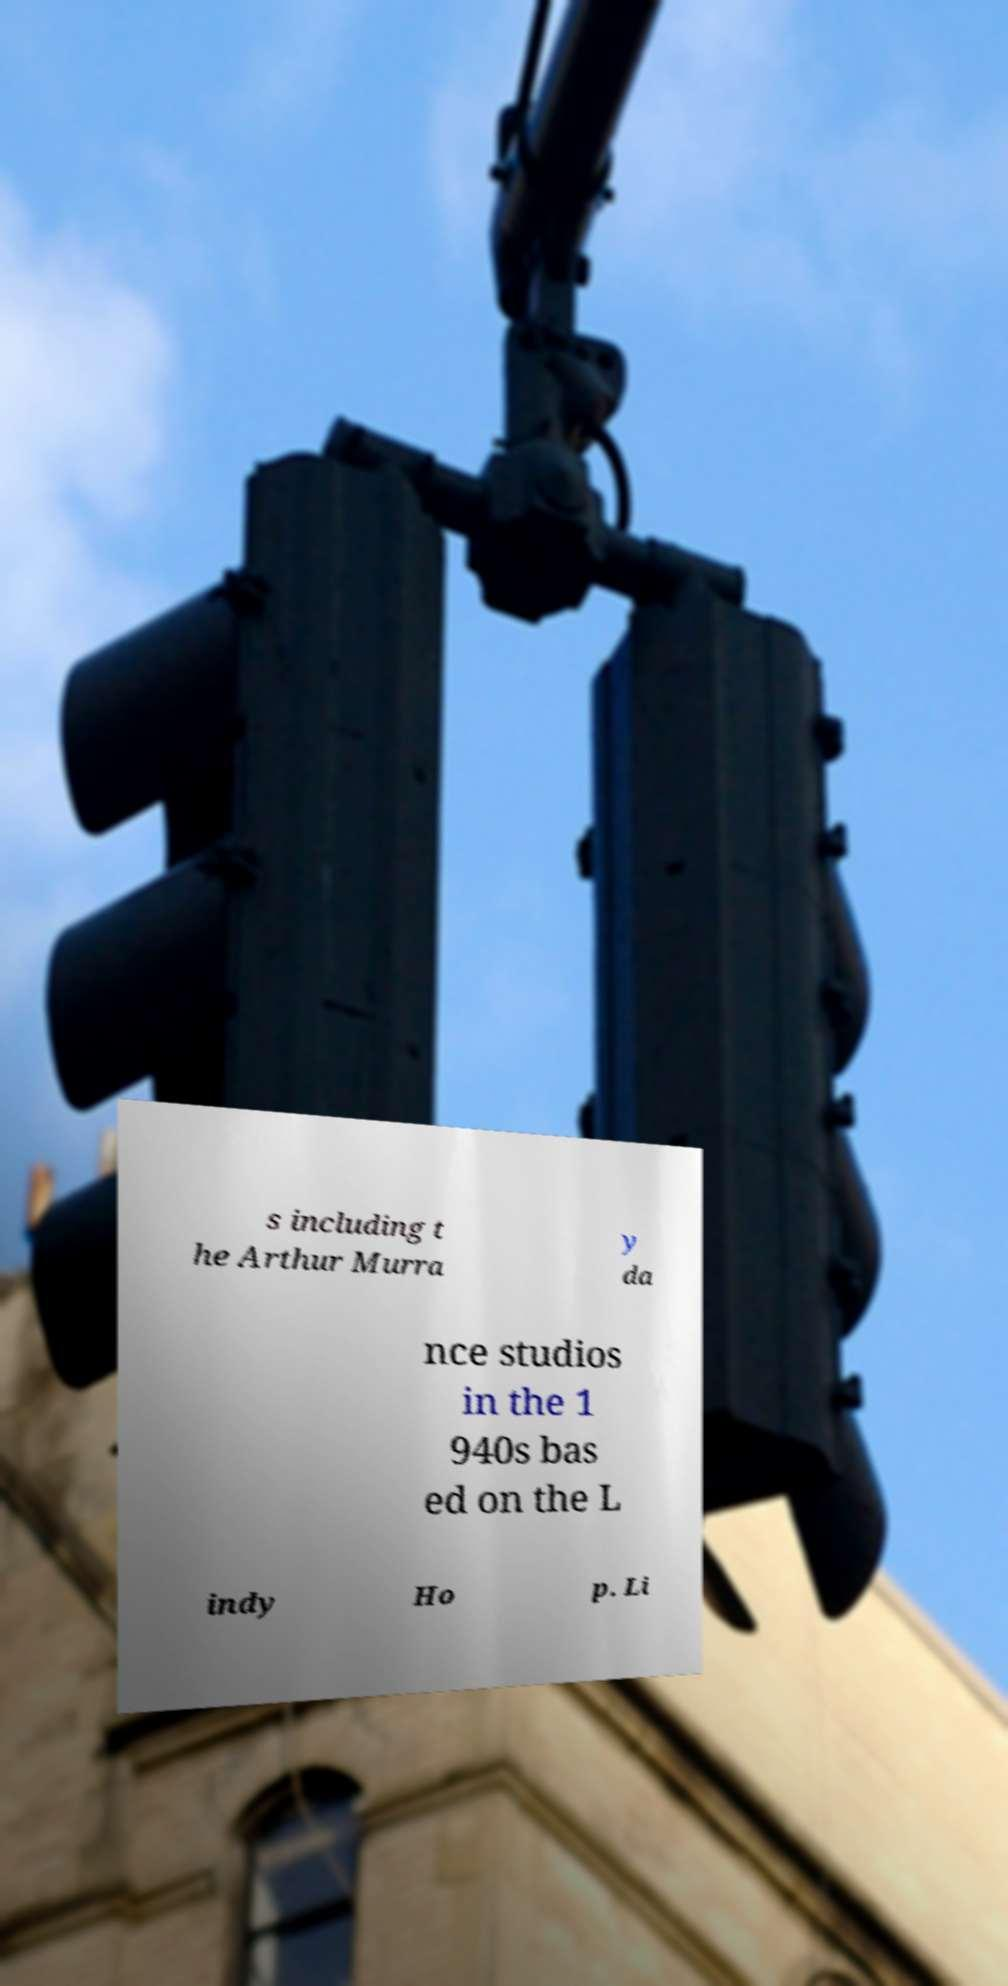Can you read and provide the text displayed in the image?This photo seems to have some interesting text. Can you extract and type it out for me? s including t he Arthur Murra y da nce studios in the 1 940s bas ed on the L indy Ho p. Li 